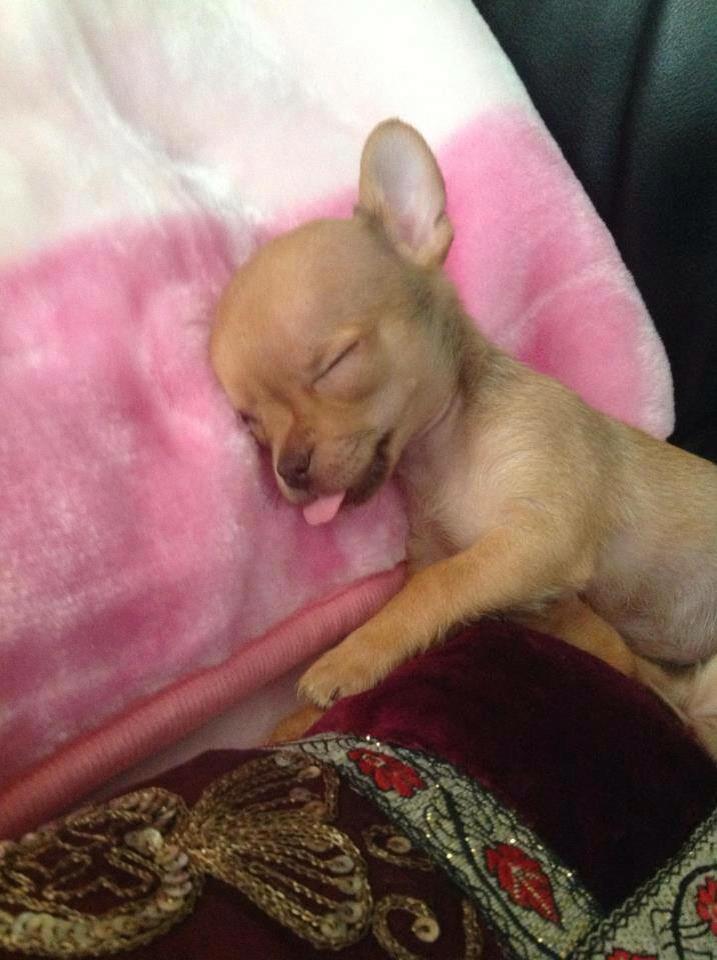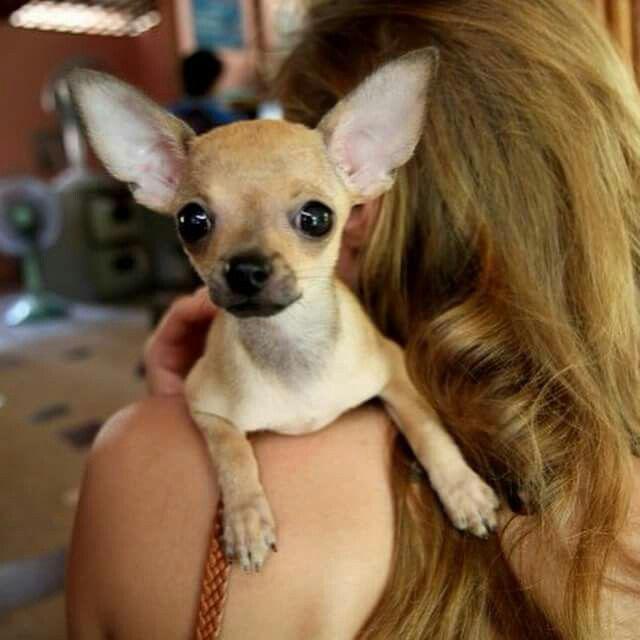The first image is the image on the left, the second image is the image on the right. Examine the images to the left and right. Is the description "There are a total of two dogs between both images." accurate? Answer yes or no. Yes. The first image is the image on the left, the second image is the image on the right. Analyze the images presented: Is the assertion "The left photo depicts two or more dogs outside in the grass." valid? Answer yes or no. No. 